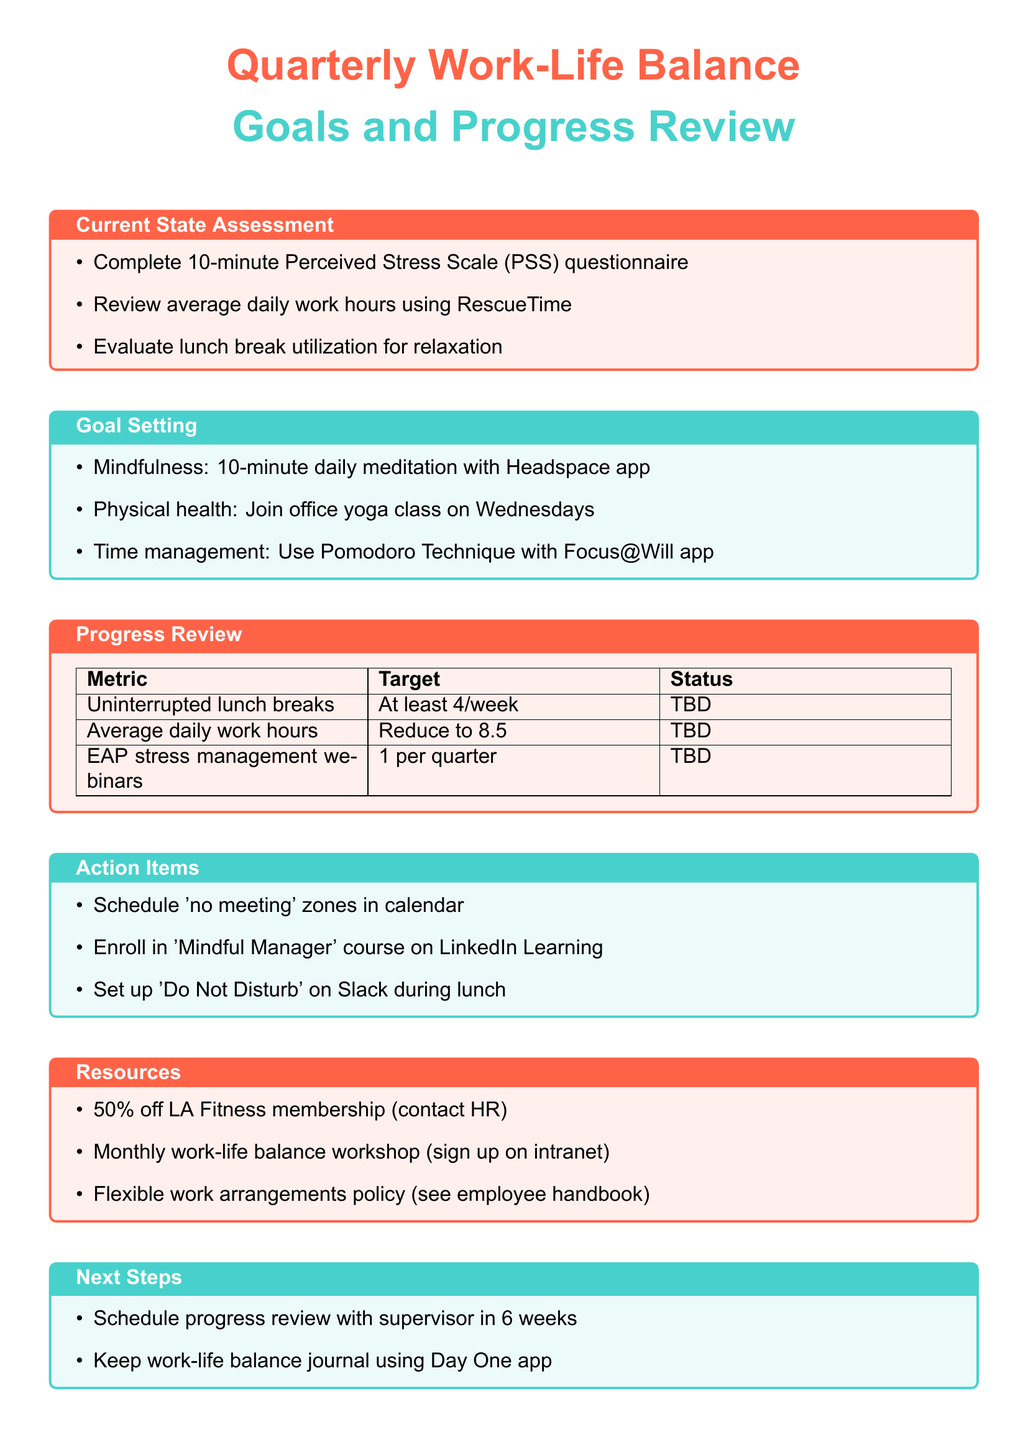What is the purpose of the meeting? The purpose is to assess and improve work-life balance for stressed-out office workers.
Answer: To assess and improve work-life balance What tool is suggested for reviewing work hours? The document mentions using the Time tracking app, specifically RescueTime, for this purpose.
Answer: RescueTime What is the target for the average daily work hours? The document specifies the target is to reduce from 9.5 to 8.5 hours.
Answer: Reduce from 9.5 to 8.5 hours How many uninterrupted lunch breaks should be taken per week? The meeting goal states at least 4 uninterrupted lunch breaks per week should be the target.
Answer: At least 4 per week What is one of the action items for employees? One of the tasks is to schedule 'no meeting' zones in the calendar for focused work and breaks.
Answer: Schedule 'no meeting' zones What is the deadline for the 'Mindful Manager' course enrollment? The deadline for enrollment is within 30 days according to the action items listed.
Answer: Within 30 days What benefit is associated with joining the office yoga class? The benefit mentioned is to improve flexibility and reduce physical tension.
Answer: Improve flexibility and reduce physical tension What is the recommended method for tracking habits? The document suggests keeping a work-life balance journal using the Day One app.
Answer: Day One app 